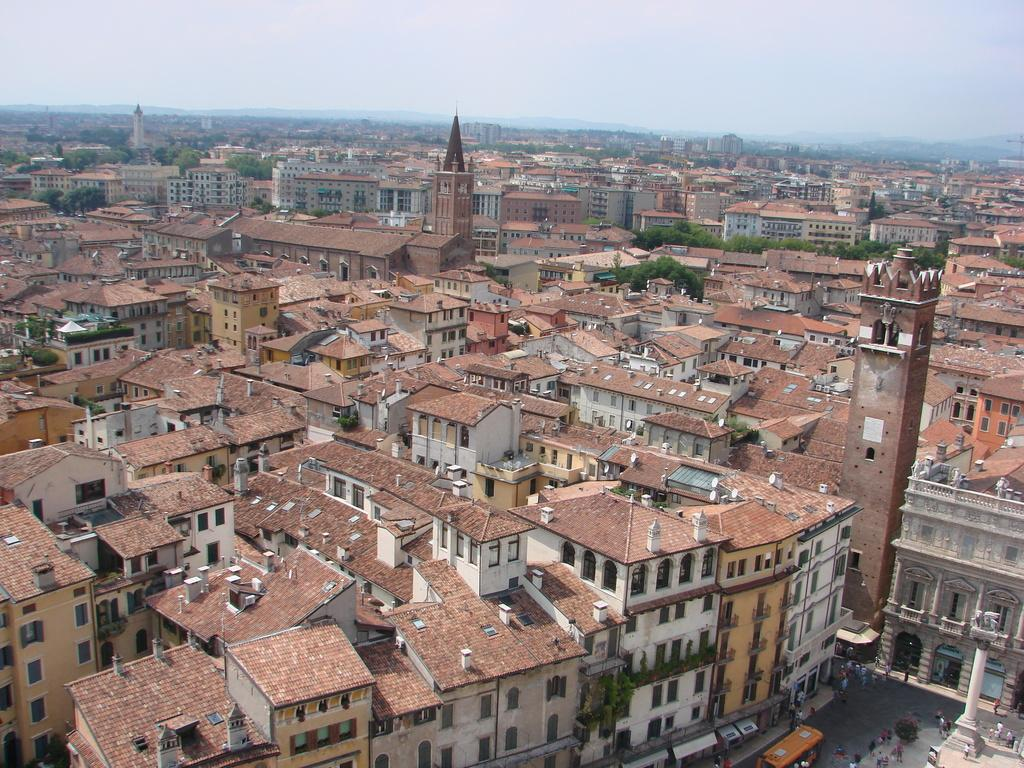What type of location is depicted in the image? The image depicts a city. What structures can be seen in the city? There are buildings in the image. What type of vegetation is present in the city? There are trees in the image. What is visible in the background of the image? The sky is visible in the background of the image. What shape is the smoke coming out of the chimney in the image? There is no smoke or chimney present in the image. What type of event is taking place in the city in the image? There is no specific event depicted in the image; it simply shows a city with buildings, trees, and the sky. 